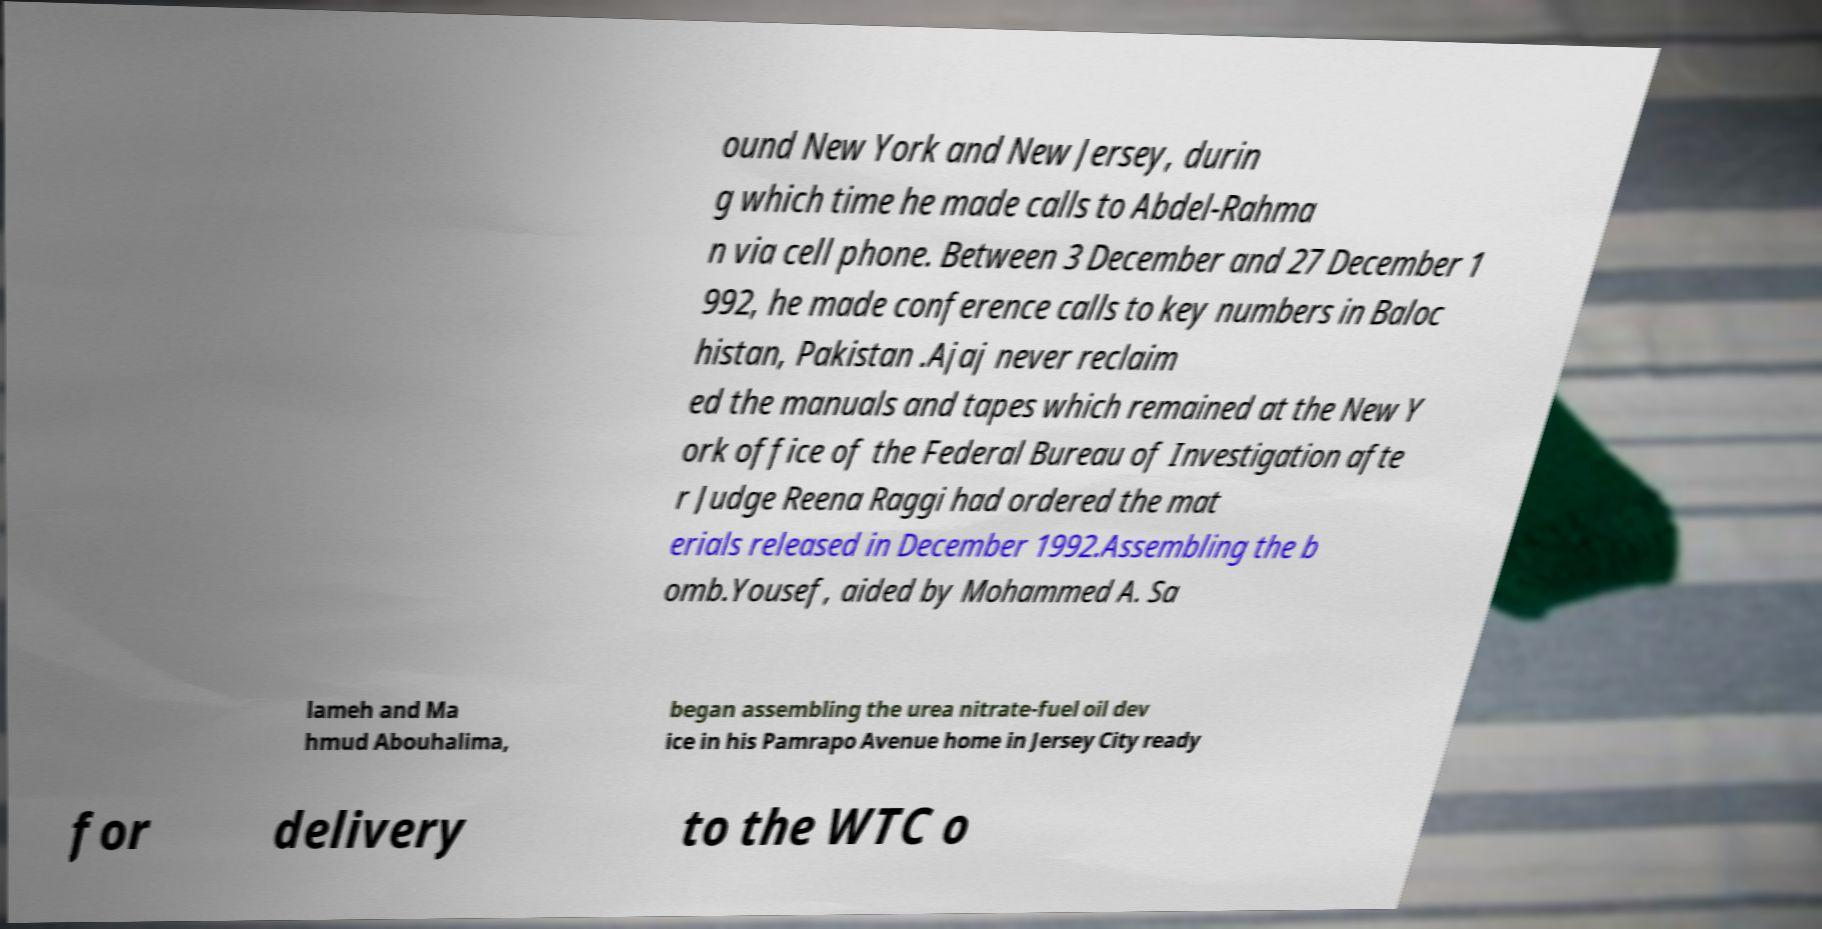Can you read and provide the text displayed in the image?This photo seems to have some interesting text. Can you extract and type it out for me? ound New York and New Jersey, durin g which time he made calls to Abdel-Rahma n via cell phone. Between 3 December and 27 December 1 992, he made conference calls to key numbers in Baloc histan, Pakistan .Ajaj never reclaim ed the manuals and tapes which remained at the New Y ork office of the Federal Bureau of Investigation afte r Judge Reena Raggi had ordered the mat erials released in December 1992.Assembling the b omb.Yousef, aided by Mohammed A. Sa lameh and Ma hmud Abouhalima, began assembling the urea nitrate-fuel oil dev ice in his Pamrapo Avenue home in Jersey City ready for delivery to the WTC o 